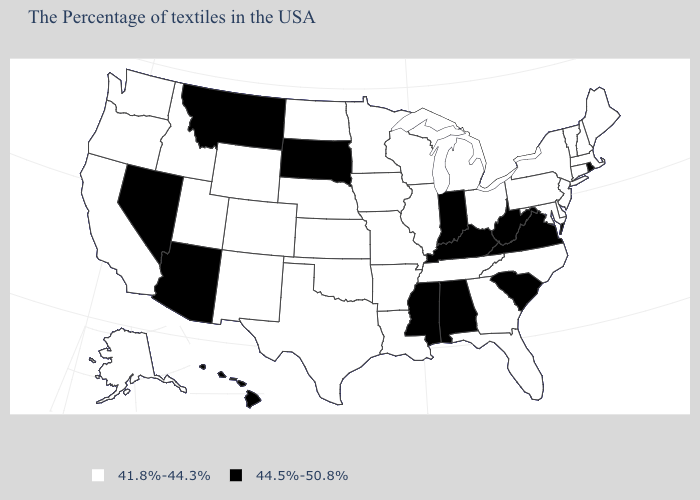Among the states that border Alabama , which have the lowest value?
Write a very short answer. Florida, Georgia, Tennessee. Name the states that have a value in the range 44.5%-50.8%?
Give a very brief answer. Rhode Island, Virginia, South Carolina, West Virginia, Kentucky, Indiana, Alabama, Mississippi, South Dakota, Montana, Arizona, Nevada, Hawaii. What is the value of Connecticut?
Keep it brief. 41.8%-44.3%. Does Alabama have the highest value in the USA?
Write a very short answer. Yes. Does Hawaii have the lowest value in the West?
Keep it brief. No. What is the highest value in states that border North Carolina?
Concise answer only. 44.5%-50.8%. Among the states that border Oregon , which have the highest value?
Answer briefly. Nevada. Name the states that have a value in the range 44.5%-50.8%?
Write a very short answer. Rhode Island, Virginia, South Carolina, West Virginia, Kentucky, Indiana, Alabama, Mississippi, South Dakota, Montana, Arizona, Nevada, Hawaii. Name the states that have a value in the range 44.5%-50.8%?
Write a very short answer. Rhode Island, Virginia, South Carolina, West Virginia, Kentucky, Indiana, Alabama, Mississippi, South Dakota, Montana, Arizona, Nevada, Hawaii. Name the states that have a value in the range 41.8%-44.3%?
Be succinct. Maine, Massachusetts, New Hampshire, Vermont, Connecticut, New York, New Jersey, Delaware, Maryland, Pennsylvania, North Carolina, Ohio, Florida, Georgia, Michigan, Tennessee, Wisconsin, Illinois, Louisiana, Missouri, Arkansas, Minnesota, Iowa, Kansas, Nebraska, Oklahoma, Texas, North Dakota, Wyoming, Colorado, New Mexico, Utah, Idaho, California, Washington, Oregon, Alaska. Does Maryland have the highest value in the South?
Concise answer only. No. Does Alabama have a higher value than North Carolina?
Write a very short answer. Yes. Name the states that have a value in the range 44.5%-50.8%?
Write a very short answer. Rhode Island, Virginia, South Carolina, West Virginia, Kentucky, Indiana, Alabama, Mississippi, South Dakota, Montana, Arizona, Nevada, Hawaii. Name the states that have a value in the range 44.5%-50.8%?
Give a very brief answer. Rhode Island, Virginia, South Carolina, West Virginia, Kentucky, Indiana, Alabama, Mississippi, South Dakota, Montana, Arizona, Nevada, Hawaii. Name the states that have a value in the range 44.5%-50.8%?
Keep it brief. Rhode Island, Virginia, South Carolina, West Virginia, Kentucky, Indiana, Alabama, Mississippi, South Dakota, Montana, Arizona, Nevada, Hawaii. 